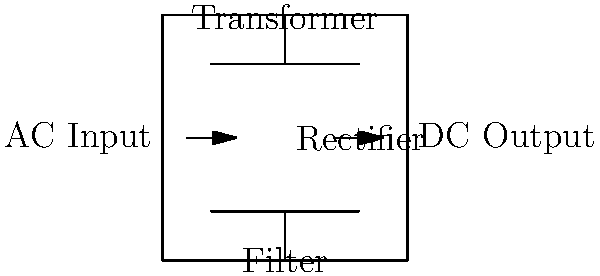In the given circuit diagram of a basic power supply, what is the correct sequence of components from input to output? To interpret this circuit diagram and determine the correct sequence of components, let's follow the flow of electricity from input to output:

1. AC Input: The circuit begins with an alternating current (AC) input on the left side.

2. Transformer: The first component encountered is the transformer. It's represented by two parallel lines at the top of the diagram. The transformer's primary function is to step up or step down the input voltage to the desired level.

3. Rectifier: Following the transformer, we see the rectifier in the middle of the diagram. The rectifier converts the AC output from the transformer into pulsating DC.

4. Filter: The last component before the output is the filter, shown at the bottom of the diagram. The filter smooths out the pulsating DC from the rectifier, reducing ripple and providing a more stable DC voltage.

5. DC Output: Finally, we reach the DC output on the right side of the diagram.

Therefore, the correct sequence of components from input to output is: AC Input → Transformer → Rectifier → Filter → DC Output.
Answer: AC Input → Transformer → Rectifier → Filter → DC Output 